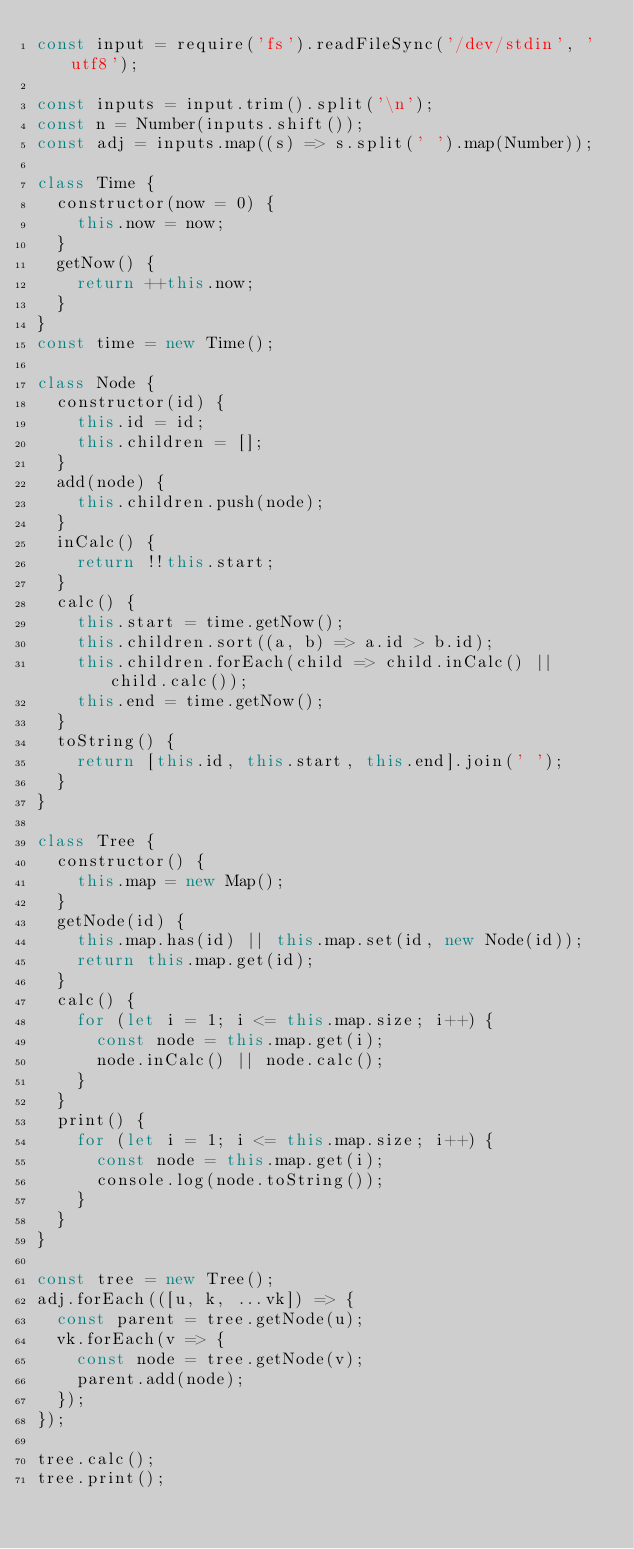<code> <loc_0><loc_0><loc_500><loc_500><_JavaScript_>const input = require('fs').readFileSync('/dev/stdin', 'utf8');

const inputs = input.trim().split('\n');
const n = Number(inputs.shift());
const adj = inputs.map((s) => s.split(' ').map(Number));

class Time {
  constructor(now = 0) {
    this.now = now;
  }
  getNow() {
    return ++this.now;
  }
}
const time = new Time();

class Node {
  constructor(id) {
    this.id = id;
    this.children = [];
  }
  add(node) {
    this.children.push(node);
  }
  inCalc() {
    return !!this.start;
  }
  calc() {
    this.start = time.getNow();
    this.children.sort((a, b) => a.id > b.id);
    this.children.forEach(child => child.inCalc() || child.calc());
    this.end = time.getNow();
  }
  toString() {
    return [this.id, this.start, this.end].join(' ');
  }
}

class Tree {
  constructor() {
    this.map = new Map();
  }
  getNode(id) {
    this.map.has(id) || this.map.set(id, new Node(id));
    return this.map.get(id);
  }
  calc() {
    for (let i = 1; i <= this.map.size; i++) {
      const node = this.map.get(i);
      node.inCalc() || node.calc();
    }
  }
  print() {
    for (let i = 1; i <= this.map.size; i++) {
      const node = this.map.get(i);
      console.log(node.toString());
    }
  }
}

const tree = new Tree();
adj.forEach(([u, k, ...vk]) => {
  const parent = tree.getNode(u);
  vk.forEach(v => {
    const node = tree.getNode(v);
    parent.add(node);
  });
});

tree.calc();
tree.print();

</code> 